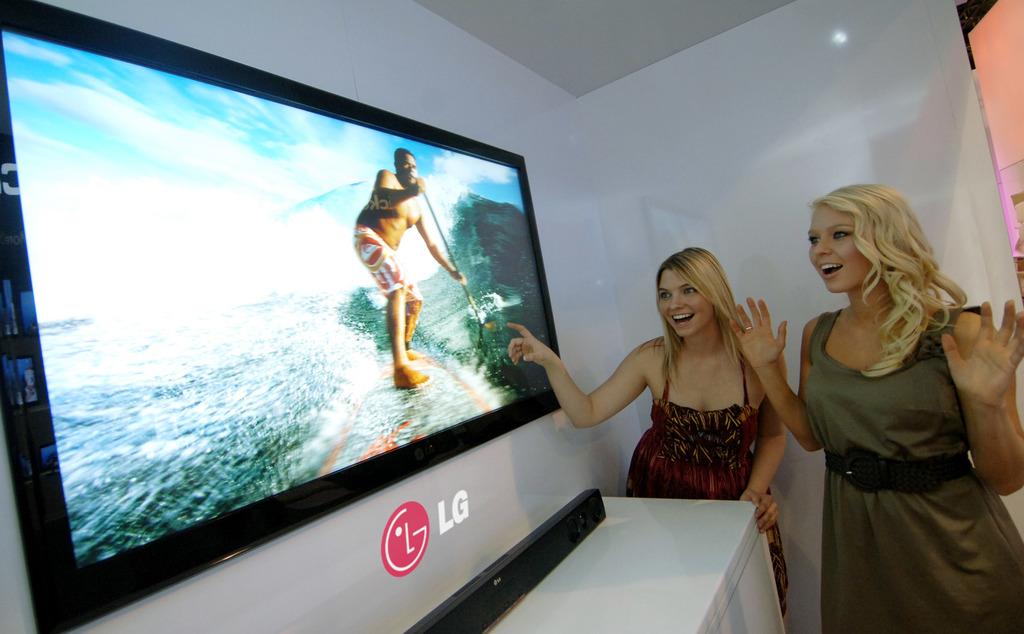What brand tv is this?
Ensure brevity in your answer.  Lg. 